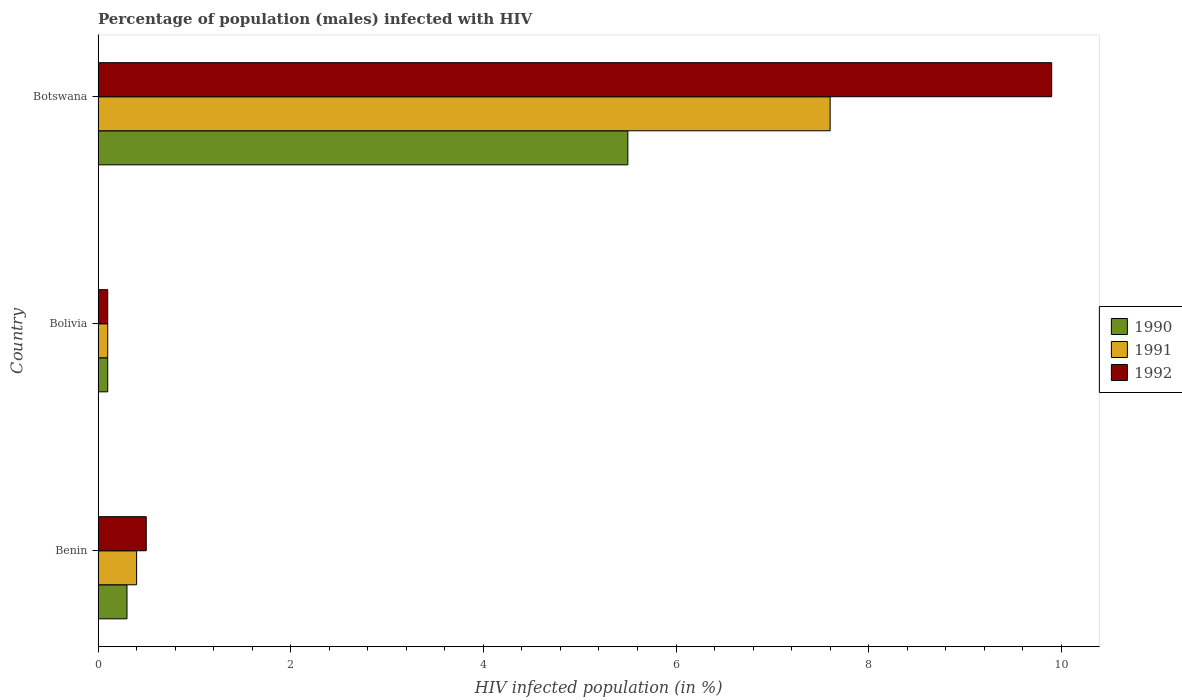How many different coloured bars are there?
Ensure brevity in your answer.  3. How many bars are there on the 3rd tick from the top?
Make the answer very short. 3. What is the label of the 3rd group of bars from the top?
Your answer should be compact. Benin. In how many cases, is the number of bars for a given country not equal to the number of legend labels?
Your answer should be compact. 0. What is the percentage of HIV infected male population in 1992 in Botswana?
Your answer should be compact. 9.9. Across all countries, what is the maximum percentage of HIV infected male population in 1992?
Your response must be concise. 9.9. Across all countries, what is the minimum percentage of HIV infected male population in 1991?
Your answer should be very brief. 0.1. In which country was the percentage of HIV infected male population in 1992 maximum?
Provide a succinct answer. Botswana. What is the total percentage of HIV infected male population in 1991 in the graph?
Your answer should be very brief. 8.1. What is the difference between the percentage of HIV infected male population in 1992 in Benin and that in Bolivia?
Your response must be concise. 0.4. What is the difference between the percentage of HIV infected male population in 1990 in Bolivia and the percentage of HIV infected male population in 1991 in Botswana?
Offer a terse response. -7.5. What is the average percentage of HIV infected male population in 1990 per country?
Offer a very short reply. 1.97. What is the ratio of the percentage of HIV infected male population in 1992 in Benin to that in Bolivia?
Ensure brevity in your answer.  5. What is the difference between the highest and the second highest percentage of HIV infected male population in 1991?
Offer a very short reply. 7.2. What is the difference between the highest and the lowest percentage of HIV infected male population in 1992?
Ensure brevity in your answer.  9.8. In how many countries, is the percentage of HIV infected male population in 1990 greater than the average percentage of HIV infected male population in 1990 taken over all countries?
Give a very brief answer. 1. Is the sum of the percentage of HIV infected male population in 1992 in Bolivia and Botswana greater than the maximum percentage of HIV infected male population in 1991 across all countries?
Keep it short and to the point. Yes. What does the 3rd bar from the bottom in Benin represents?
Provide a short and direct response. 1992. Is it the case that in every country, the sum of the percentage of HIV infected male population in 1991 and percentage of HIV infected male population in 1992 is greater than the percentage of HIV infected male population in 1990?
Provide a short and direct response. Yes. How many countries are there in the graph?
Give a very brief answer. 3. Are the values on the major ticks of X-axis written in scientific E-notation?
Make the answer very short. No. Does the graph contain grids?
Your response must be concise. No. How many legend labels are there?
Offer a very short reply. 3. What is the title of the graph?
Keep it short and to the point. Percentage of population (males) infected with HIV. Does "1997" appear as one of the legend labels in the graph?
Give a very brief answer. No. What is the label or title of the X-axis?
Keep it short and to the point. HIV infected population (in %). What is the HIV infected population (in %) in 1991 in Benin?
Give a very brief answer. 0.4. What is the HIV infected population (in %) in 1992 in Benin?
Provide a succinct answer. 0.5. What is the HIV infected population (in %) in 1991 in Bolivia?
Your answer should be compact. 0.1. What is the HIV infected population (in %) in 1992 in Bolivia?
Make the answer very short. 0.1. What is the HIV infected population (in %) in 1990 in Botswana?
Your response must be concise. 5.5. What is the HIV infected population (in %) in 1991 in Botswana?
Ensure brevity in your answer.  7.6. What is the HIV infected population (in %) in 1992 in Botswana?
Your answer should be compact. 9.9. Across all countries, what is the maximum HIV infected population (in %) of 1991?
Provide a short and direct response. 7.6. Across all countries, what is the maximum HIV infected population (in %) of 1992?
Keep it short and to the point. 9.9. Across all countries, what is the minimum HIV infected population (in %) of 1990?
Your answer should be compact. 0.1. Across all countries, what is the minimum HIV infected population (in %) of 1992?
Provide a succinct answer. 0.1. What is the total HIV infected population (in %) in 1990 in the graph?
Keep it short and to the point. 5.9. What is the total HIV infected population (in %) of 1991 in the graph?
Your response must be concise. 8.1. What is the difference between the HIV infected population (in %) of 1990 in Benin and that in Botswana?
Ensure brevity in your answer.  -5.2. What is the difference between the HIV infected population (in %) in 1991 in Benin and that in Botswana?
Your response must be concise. -7.2. What is the difference between the HIV infected population (in %) of 1992 in Benin and that in Botswana?
Make the answer very short. -9.4. What is the difference between the HIV infected population (in %) of 1992 in Bolivia and that in Botswana?
Your response must be concise. -9.8. What is the difference between the HIV infected population (in %) of 1990 in Benin and the HIV infected population (in %) of 1991 in Bolivia?
Keep it short and to the point. 0.2. What is the difference between the HIV infected population (in %) of 1990 in Benin and the HIV infected population (in %) of 1992 in Bolivia?
Your answer should be very brief. 0.2. What is the difference between the HIV infected population (in %) in 1991 in Benin and the HIV infected population (in %) in 1992 in Bolivia?
Provide a succinct answer. 0.3. What is the difference between the HIV infected population (in %) in 1990 in Benin and the HIV infected population (in %) in 1991 in Botswana?
Keep it short and to the point. -7.3. What is the difference between the HIV infected population (in %) of 1990 in Benin and the HIV infected population (in %) of 1992 in Botswana?
Provide a short and direct response. -9.6. What is the difference between the HIV infected population (in %) of 1990 in Bolivia and the HIV infected population (in %) of 1991 in Botswana?
Provide a short and direct response. -7.5. What is the difference between the HIV infected population (in %) in 1990 in Bolivia and the HIV infected population (in %) in 1992 in Botswana?
Your answer should be compact. -9.8. What is the average HIV infected population (in %) in 1990 per country?
Give a very brief answer. 1.97. What is the average HIV infected population (in %) of 1991 per country?
Give a very brief answer. 2.7. What is the difference between the HIV infected population (in %) of 1990 and HIV infected population (in %) of 1992 in Benin?
Your answer should be very brief. -0.2. What is the difference between the HIV infected population (in %) of 1991 and HIV infected population (in %) of 1992 in Botswana?
Provide a short and direct response. -2.3. What is the ratio of the HIV infected population (in %) of 1990 in Benin to that in Bolivia?
Make the answer very short. 3. What is the ratio of the HIV infected population (in %) of 1991 in Benin to that in Bolivia?
Keep it short and to the point. 4. What is the ratio of the HIV infected population (in %) in 1990 in Benin to that in Botswana?
Ensure brevity in your answer.  0.05. What is the ratio of the HIV infected population (in %) in 1991 in Benin to that in Botswana?
Provide a short and direct response. 0.05. What is the ratio of the HIV infected population (in %) of 1992 in Benin to that in Botswana?
Your answer should be very brief. 0.05. What is the ratio of the HIV infected population (in %) in 1990 in Bolivia to that in Botswana?
Your answer should be compact. 0.02. What is the ratio of the HIV infected population (in %) of 1991 in Bolivia to that in Botswana?
Keep it short and to the point. 0.01. What is the ratio of the HIV infected population (in %) of 1992 in Bolivia to that in Botswana?
Provide a short and direct response. 0.01. What is the difference between the highest and the second highest HIV infected population (in %) of 1991?
Your response must be concise. 7.2. What is the difference between the highest and the second highest HIV infected population (in %) in 1992?
Ensure brevity in your answer.  9.4. What is the difference between the highest and the lowest HIV infected population (in %) of 1990?
Provide a short and direct response. 5.4. 